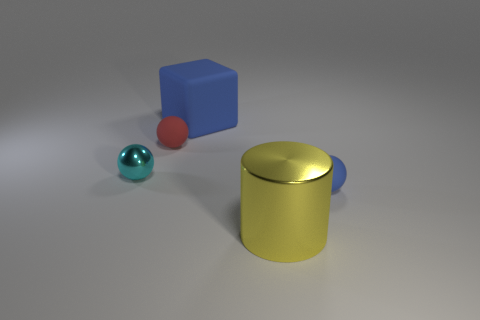How are the shadows cast by the objects? The shadows indicate a light source coming from the upper right side of the image. Each object casts a definite shadow to its left and slightly downward, following the laws of perspective and light. The shadows are soft-edged, suggesting that the light source is not extremely close to the objects. 